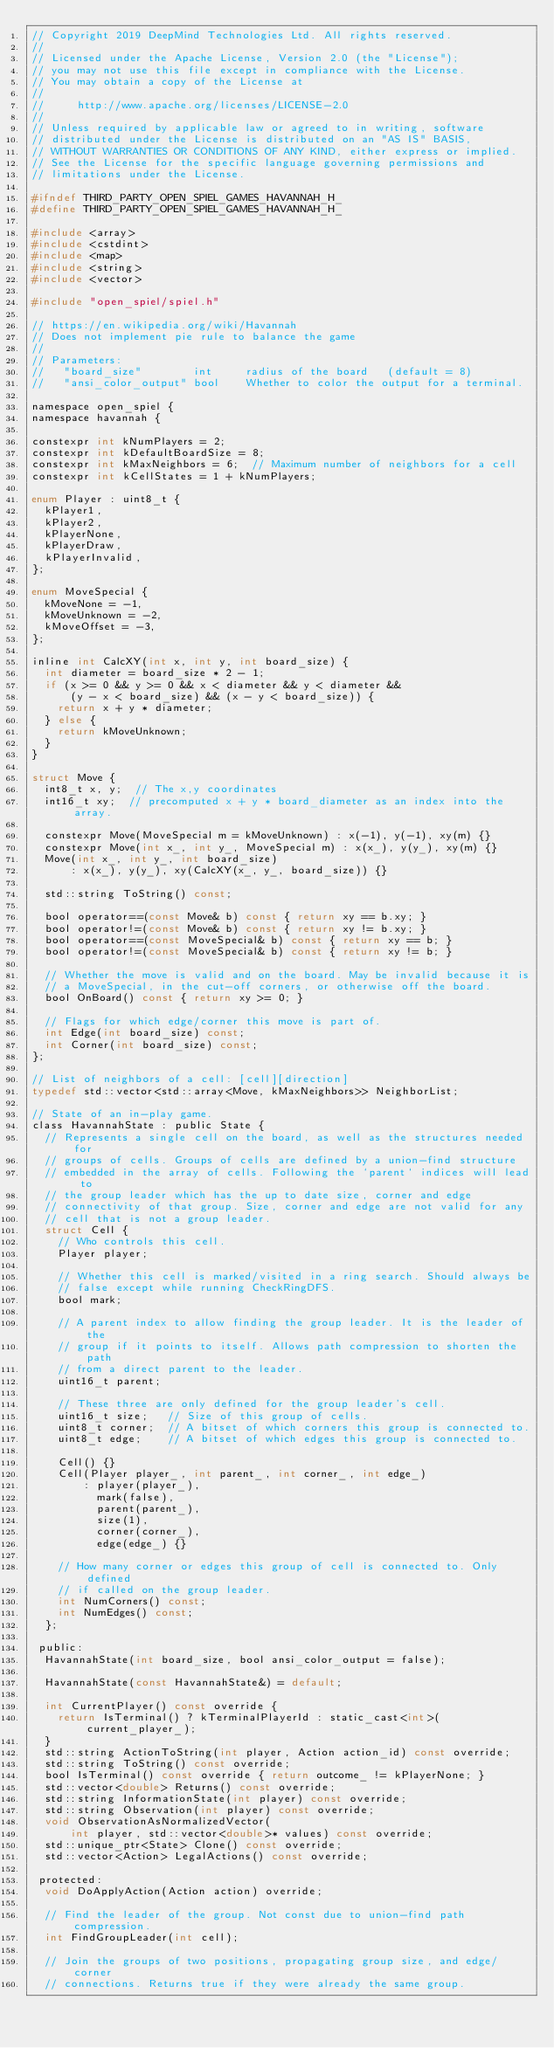Convert code to text. <code><loc_0><loc_0><loc_500><loc_500><_C_>// Copyright 2019 DeepMind Technologies Ltd. All rights reserved.
//
// Licensed under the Apache License, Version 2.0 (the "License");
// you may not use this file except in compliance with the License.
// You may obtain a copy of the License at
//
//     http://www.apache.org/licenses/LICENSE-2.0
//
// Unless required by applicable law or agreed to in writing, software
// distributed under the License is distributed on an "AS IS" BASIS,
// WITHOUT WARRANTIES OR CONDITIONS OF ANY KIND, either express or implied.
// See the License for the specific language governing permissions and
// limitations under the License.

#ifndef THIRD_PARTY_OPEN_SPIEL_GAMES_HAVANNAH_H_
#define THIRD_PARTY_OPEN_SPIEL_GAMES_HAVANNAH_H_

#include <array>
#include <cstdint>
#include <map>
#include <string>
#include <vector>

#include "open_spiel/spiel.h"

// https://en.wikipedia.org/wiki/Havannah
// Does not implement pie rule to balance the game
//
// Parameters:
//   "board_size"        int     radius of the board   (default = 8)
//   "ansi_color_output" bool    Whether to color the output for a terminal.

namespace open_spiel {
namespace havannah {

constexpr int kNumPlayers = 2;
constexpr int kDefaultBoardSize = 8;
constexpr int kMaxNeighbors = 6;  // Maximum number of neighbors for a cell
constexpr int kCellStates = 1 + kNumPlayers;

enum Player : uint8_t {
  kPlayer1,
  kPlayer2,
  kPlayerNone,
  kPlayerDraw,
  kPlayerInvalid,
};

enum MoveSpecial {
  kMoveNone = -1,
  kMoveUnknown = -2,
  kMoveOffset = -3,
};

inline int CalcXY(int x, int y, int board_size) {
  int diameter = board_size * 2 - 1;
  if (x >= 0 && y >= 0 && x < diameter && y < diameter &&
      (y - x < board_size) && (x - y < board_size)) {
    return x + y * diameter;
  } else {
    return kMoveUnknown;
  }
}

struct Move {
  int8_t x, y;  // The x,y coordinates
  int16_t xy;  // precomputed x + y * board_diameter as an index into the array.

  constexpr Move(MoveSpecial m = kMoveUnknown) : x(-1), y(-1), xy(m) {}
  constexpr Move(int x_, int y_, MoveSpecial m) : x(x_), y(y_), xy(m) {}
  Move(int x_, int y_, int board_size)
      : x(x_), y(y_), xy(CalcXY(x_, y_, board_size)) {}

  std::string ToString() const;

  bool operator==(const Move& b) const { return xy == b.xy; }
  bool operator!=(const Move& b) const { return xy != b.xy; }
  bool operator==(const MoveSpecial& b) const { return xy == b; }
  bool operator!=(const MoveSpecial& b) const { return xy != b; }

  // Whether the move is valid and on the board. May be invalid because it is
  // a MoveSpecial, in the cut-off corners, or otherwise off the board.
  bool OnBoard() const { return xy >= 0; }

  // Flags for which edge/corner this move is part of.
  int Edge(int board_size) const;
  int Corner(int board_size) const;
};

// List of neighbors of a cell: [cell][direction]
typedef std::vector<std::array<Move, kMaxNeighbors>> NeighborList;

// State of an in-play game.
class HavannahState : public State {
  // Represents a single cell on the board, as well as the structures needed for
  // groups of cells. Groups of cells are defined by a union-find structure
  // embedded in the array of cells. Following the `parent` indices will lead to
  // the group leader which has the up to date size, corner and edge
  // connectivity of that group. Size, corner and edge are not valid for any
  // cell that is not a group leader.
  struct Cell {
    // Who controls this cell.
    Player player;

    // Whether this cell is marked/visited in a ring search. Should always be
    // false except while running CheckRingDFS.
    bool mark;

    // A parent index to allow finding the group leader. It is the leader of the
    // group if it points to itself. Allows path compression to shorten the path
    // from a direct parent to the leader.
    uint16_t parent;

    // These three are only defined for the group leader's cell.
    uint16_t size;   // Size of this group of cells.
    uint8_t corner;  // A bitset of which corners this group is connected to.
    uint8_t edge;    // A bitset of which edges this group is connected to.

    Cell() {}
    Cell(Player player_, int parent_, int corner_, int edge_)
        : player(player_),
          mark(false),
          parent(parent_),
          size(1),
          corner(corner_),
          edge(edge_) {}

    // How many corner or edges this group of cell is connected to. Only defined
    // if called on the group leader.
    int NumCorners() const;
    int NumEdges() const;
  };

 public:
  HavannahState(int board_size, bool ansi_color_output = false);

  HavannahState(const HavannahState&) = default;

  int CurrentPlayer() const override {
    return IsTerminal() ? kTerminalPlayerId : static_cast<int>(current_player_);
  }
  std::string ActionToString(int player, Action action_id) const override;
  std::string ToString() const override;
  bool IsTerminal() const override { return outcome_ != kPlayerNone; }
  std::vector<double> Returns() const override;
  std::string InformationState(int player) const override;
  std::string Observation(int player) const override;
  void ObservationAsNormalizedVector(
      int player, std::vector<double>* values) const override;
  std::unique_ptr<State> Clone() const override;
  std::vector<Action> LegalActions() const override;

 protected:
  void DoApplyAction(Action action) override;

  // Find the leader of the group. Not const due to union-find path compression.
  int FindGroupLeader(int cell);

  // Join the groups of two positions, propagating group size, and edge/corner
  // connections. Returns true if they were already the same group.</code> 